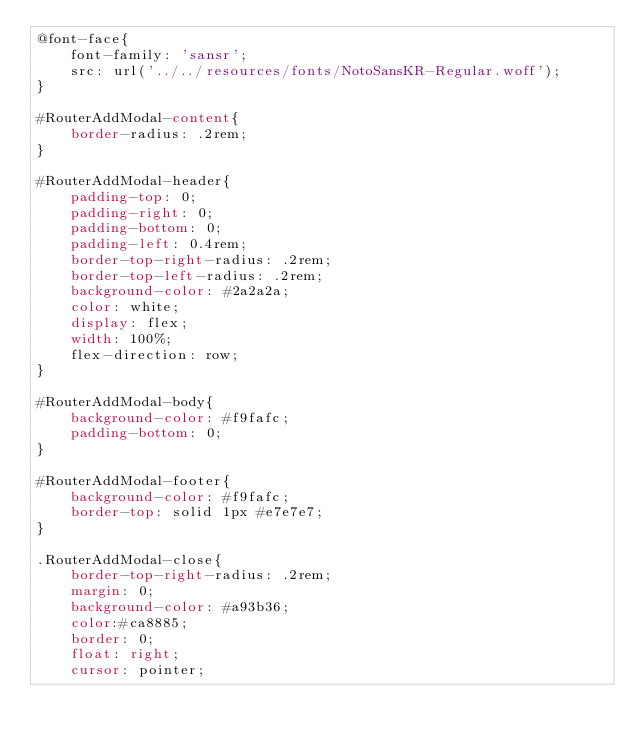Convert code to text. <code><loc_0><loc_0><loc_500><loc_500><_CSS_>@font-face{
    font-family: 'sansr';
    src: url('../../resources/fonts/NotoSansKR-Regular.woff');
}

#RouterAddModal-content{
    border-radius: .2rem;
}

#RouterAddModal-header{
    padding-top: 0;
    padding-right: 0;
    padding-bottom: 0;
    padding-left: 0.4rem;
    border-top-right-radius: .2rem;
    border-top-left-radius: .2rem;
    background-color: #2a2a2a;
    color: white;
    display: flex;
    width: 100%;
    flex-direction: row;
}

#RouterAddModal-body{
    background-color: #f9fafc;
    padding-bottom: 0;
}

#RouterAddModal-footer{
    background-color: #f9fafc;
    border-top: solid 1px #e7e7e7;
}

.RouterAddModal-close{
    border-top-right-radius: .2rem;
    margin: 0;
    background-color: #a93b36;
    color:#ca8885;
    border: 0;
    float: right;
    cursor: pointer;</code> 